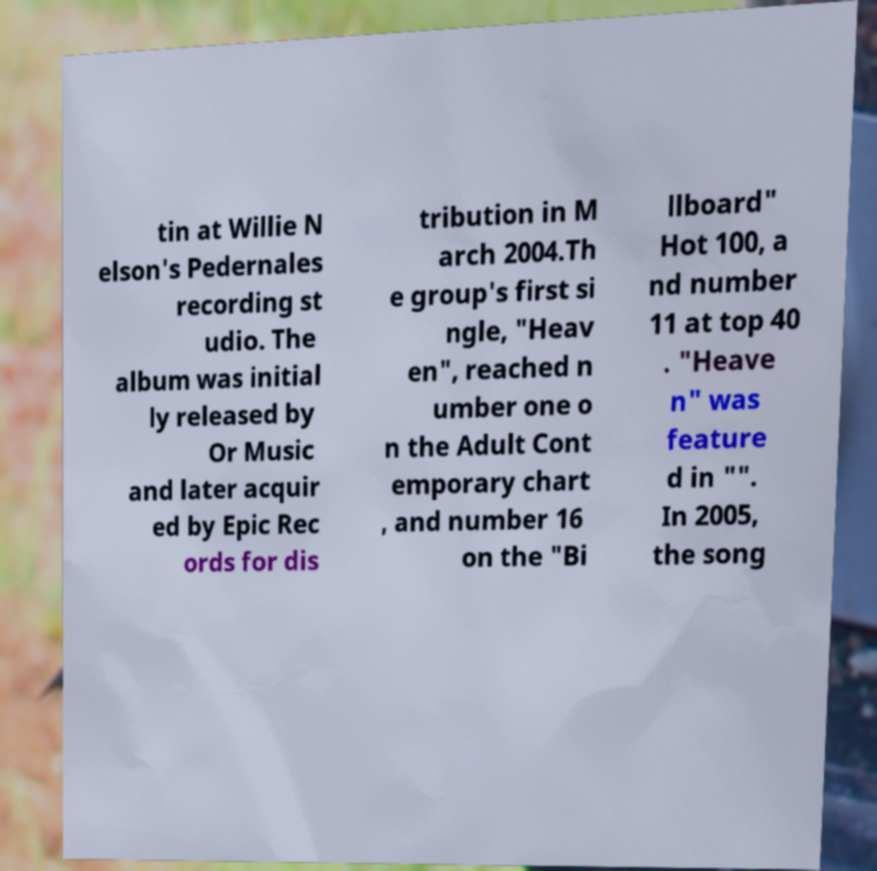There's text embedded in this image that I need extracted. Can you transcribe it verbatim? tin at Willie N elson's Pedernales recording st udio. The album was initial ly released by Or Music and later acquir ed by Epic Rec ords for dis tribution in M arch 2004.Th e group's first si ngle, "Heav en", reached n umber one o n the Adult Cont emporary chart , and number 16 on the "Bi llboard" Hot 100, a nd number 11 at top 40 . "Heave n" was feature d in "". In 2005, the song 